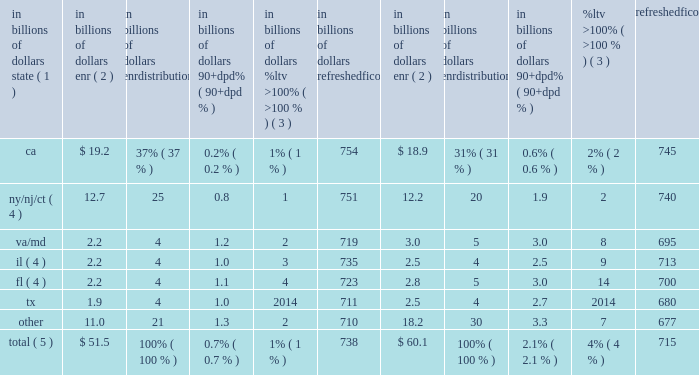During 2015 , continued management actions , primarily the sale or transfer to held-for-sale of approximately $ 1.5 billion of delinquent residential first mortgages , including $ 0.9 billion in the fourth quarter largely associated with the transfer of citifinancial loans to held-for-sale referenced above , were the primary driver of the overall improvement in delinquencies within citi holdings 2019 residential first mortgage portfolio .
Credit performance from quarter to quarter could continue to be impacted by the amount of delinquent loan sales or transfers to held-for-sale , as well as overall trends in hpi and interest rates .
North america residential first mortgages 2014state delinquency trends the tables set forth the six u.s .
States and/or regions with the highest concentration of citi 2019s residential first mortgages. .
Total ( 5 ) $ 51.5 100% ( 100 % ) 0.7% ( 0.7 % ) 1% ( 1 % ) 738 $ 60.1 100% ( 100 % ) 2.1% ( 2.1 % ) 4% ( 4 % ) 715 note : totals may not sum due to rounding .
( 1 ) certain of the states are included as part of a region based on citi 2019s view of similar hpi within the region .
( 2 ) ending net receivables .
Excludes loans in canada and puerto rico , loans guaranteed by u.s .
Government agencies , loans recorded at fair value and loans subject to long term standby commitments ( ltscs ) .
Excludes balances for which fico or ltv data are unavailable .
( 3 ) ltv ratios ( loan balance divided by appraised value ) are calculated at origination and updated by applying market price data .
( 4 ) new york , new jersey , connecticut , florida and illinois are judicial states .
( 5 ) improvement in state trends during 2015 was primarily due to the sale or transfer to held-for-sale of residential first mortgages , including the transfer of citifinancial residential first mortgages to held-for-sale in the fourth quarter of 2015 .
Foreclosures a substantial majority of citi 2019s foreclosure inventory consists of residential first mortgages .
At december 31 , 2015 , citi 2019s foreclosure inventory included approximately $ 0.1 billion , or 0.2% ( 0.2 % ) , of the total residential first mortgage portfolio , compared to $ 0.6 billion , or 0.9% ( 0.9 % ) , at december 31 , 2014 , based on the dollar amount of ending net receivables of loans in foreclosure inventory , excluding loans that are guaranteed by u.s .
Government agencies and loans subject to ltscs .
North america consumer mortgage quarterly credit trends 2014net credit losses and delinquencies 2014home equity citi 2019s home equity loan portfolio consists of both fixed-rate home equity loans and loans extended under home equity lines of credit .
Fixed-rate home equity loans are fully amortizing .
Home equity lines of credit allow for amounts to be drawn for a period of time with the payment of interest only and then , at the end of the draw period , the then-outstanding amount is converted to an amortizing loan ( the interest-only payment feature during the revolving period is standard for this product across the industry ) .
After conversion , the home equity loans typically have a 20-year amortization period .
As of december 31 , 2015 , citi 2019s home equity loan portfolio of $ 22.8 billion consisted of $ 6.3 billion of fixed-rate home equity loans and $ 16.5 billion of loans extended under home equity lines of credit ( revolving helocs ) . .
What percentage of citi's home equity portfolio as of december 31 , 2015 was comprised of fixed-rate home equity loans? 
Computations: (6.3 / 22.8)
Answer: 0.27632. 